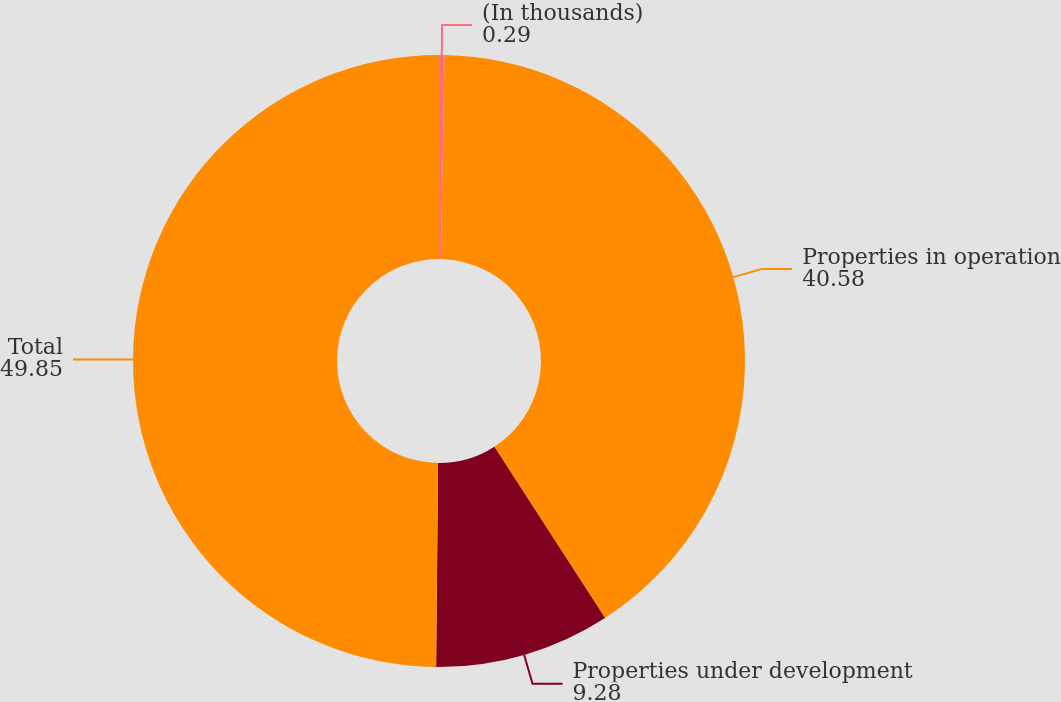Convert chart to OTSL. <chart><loc_0><loc_0><loc_500><loc_500><pie_chart><fcel>(In thousands)<fcel>Properties in operation<fcel>Properties under development<fcel>Total<nl><fcel>0.29%<fcel>40.58%<fcel>9.28%<fcel>49.85%<nl></chart> 